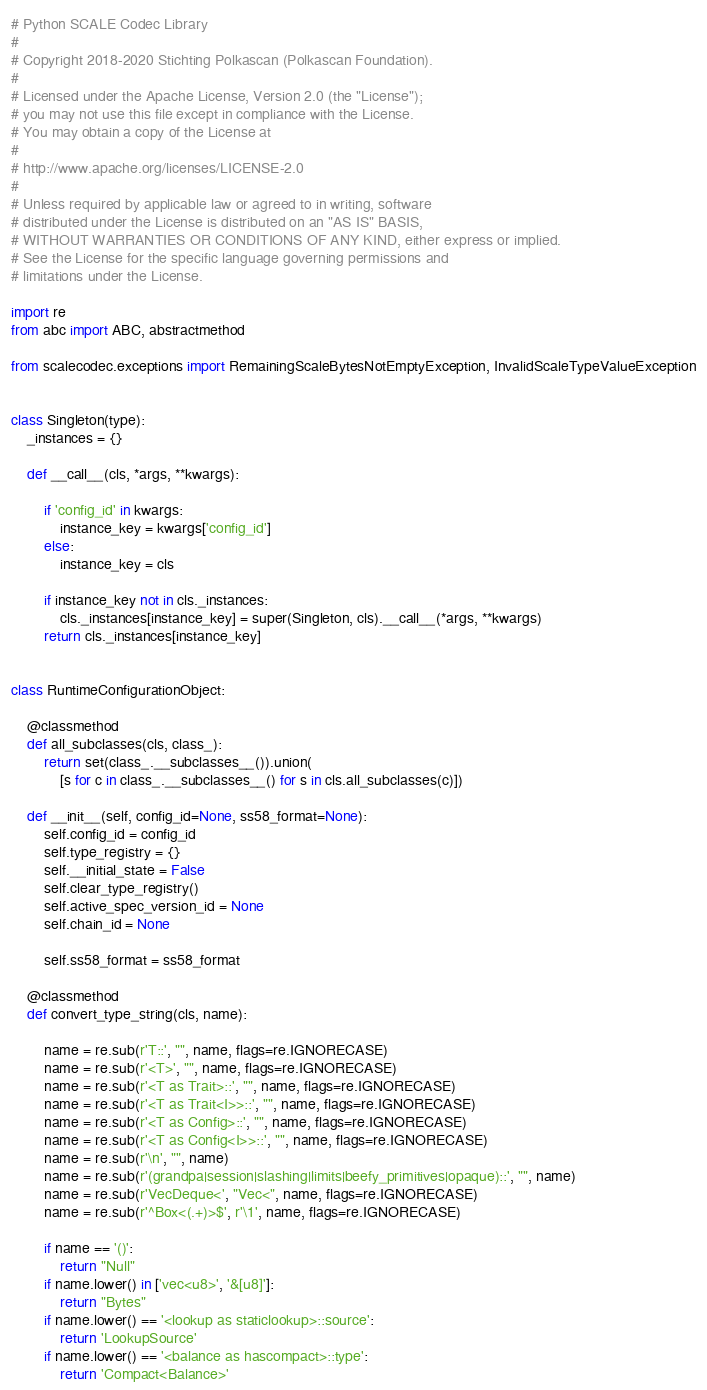<code> <loc_0><loc_0><loc_500><loc_500><_Python_># Python SCALE Codec Library
#
# Copyright 2018-2020 Stichting Polkascan (Polkascan Foundation).
#
# Licensed under the Apache License, Version 2.0 (the "License");
# you may not use this file except in compliance with the License.
# You may obtain a copy of the License at
#
# http://www.apache.org/licenses/LICENSE-2.0
#
# Unless required by applicable law or agreed to in writing, software
# distributed under the License is distributed on an "AS IS" BASIS,
# WITHOUT WARRANTIES OR CONDITIONS OF ANY KIND, either express or implied.
# See the License for the specific language governing permissions and
# limitations under the License.

import re
from abc import ABC, abstractmethod

from scalecodec.exceptions import RemainingScaleBytesNotEmptyException, InvalidScaleTypeValueException


class Singleton(type):
    _instances = {}

    def __call__(cls, *args, **kwargs):

        if 'config_id' in kwargs:
            instance_key = kwargs['config_id']
        else:
            instance_key = cls

        if instance_key not in cls._instances:
            cls._instances[instance_key] = super(Singleton, cls).__call__(*args, **kwargs)
        return cls._instances[instance_key]


class RuntimeConfigurationObject:

    @classmethod
    def all_subclasses(cls, class_):
        return set(class_.__subclasses__()).union(
            [s for c in class_.__subclasses__() for s in cls.all_subclasses(c)])

    def __init__(self, config_id=None, ss58_format=None):
        self.config_id = config_id
        self.type_registry = {}
        self.__initial_state = False
        self.clear_type_registry()
        self.active_spec_version_id = None
        self.chain_id = None

        self.ss58_format = ss58_format

    @classmethod
    def convert_type_string(cls, name):

        name = re.sub(r'T::', "", name, flags=re.IGNORECASE)
        name = re.sub(r'<T>', "", name, flags=re.IGNORECASE)
        name = re.sub(r'<T as Trait>::', "", name, flags=re.IGNORECASE)
        name = re.sub(r'<T as Trait<I>>::', "", name, flags=re.IGNORECASE)
        name = re.sub(r'<T as Config>::', "", name, flags=re.IGNORECASE)
        name = re.sub(r'<T as Config<I>>::', "", name, flags=re.IGNORECASE)
        name = re.sub(r'\n', "", name)
        name = re.sub(r'(grandpa|session|slashing|limits|beefy_primitives|opaque)::', "", name)
        name = re.sub(r'VecDeque<', "Vec<", name, flags=re.IGNORECASE)
        name = re.sub(r'^Box<(.+)>$', r'\1', name, flags=re.IGNORECASE)

        if name == '()':
            return "Null"
        if name.lower() in ['vec<u8>', '&[u8]']:
            return "Bytes"
        if name.lower() == '<lookup as staticlookup>::source':
            return 'LookupSource'
        if name.lower() == '<balance as hascompact>::type':
            return 'Compact<Balance>'</code> 